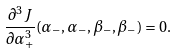<formula> <loc_0><loc_0><loc_500><loc_500>\frac { \partial ^ { 3 } J } { \partial \alpha _ { + } ^ { 3 } } ( \alpha _ { - } , \alpha _ { - } , \beta _ { - } , \beta _ { - } ) = 0 .</formula> 